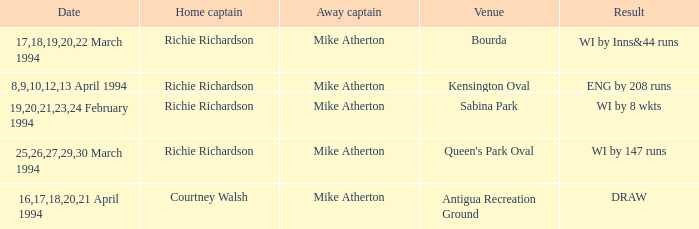What is the Venue which has a Wi by 8 wkts? Sabina Park. 